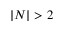<formula> <loc_0><loc_0><loc_500><loc_500>| N | > 2</formula> 